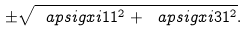<formula> <loc_0><loc_0><loc_500><loc_500>\pm \sqrt { \ a p s i g x i { 1 } { 1 } ^ { 2 } + \ a p s i g x i { 3 } { 1 } ^ { 2 } } .</formula> 